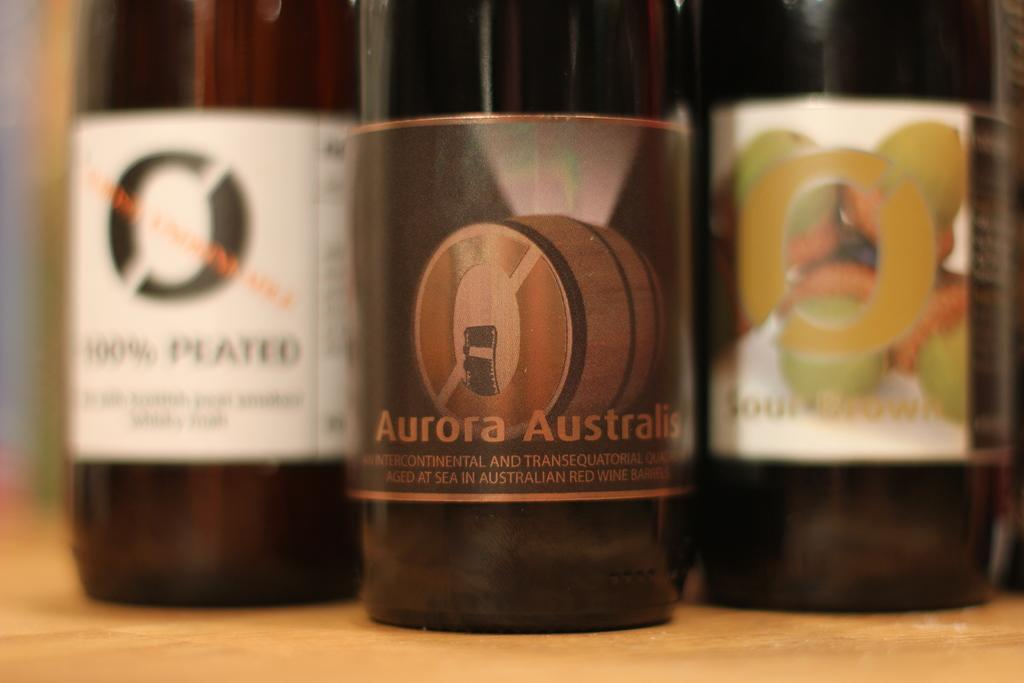<image>
Share a concise interpretation of the image provided. Several wine bottles together on a table and one has the word aurora on the label. 